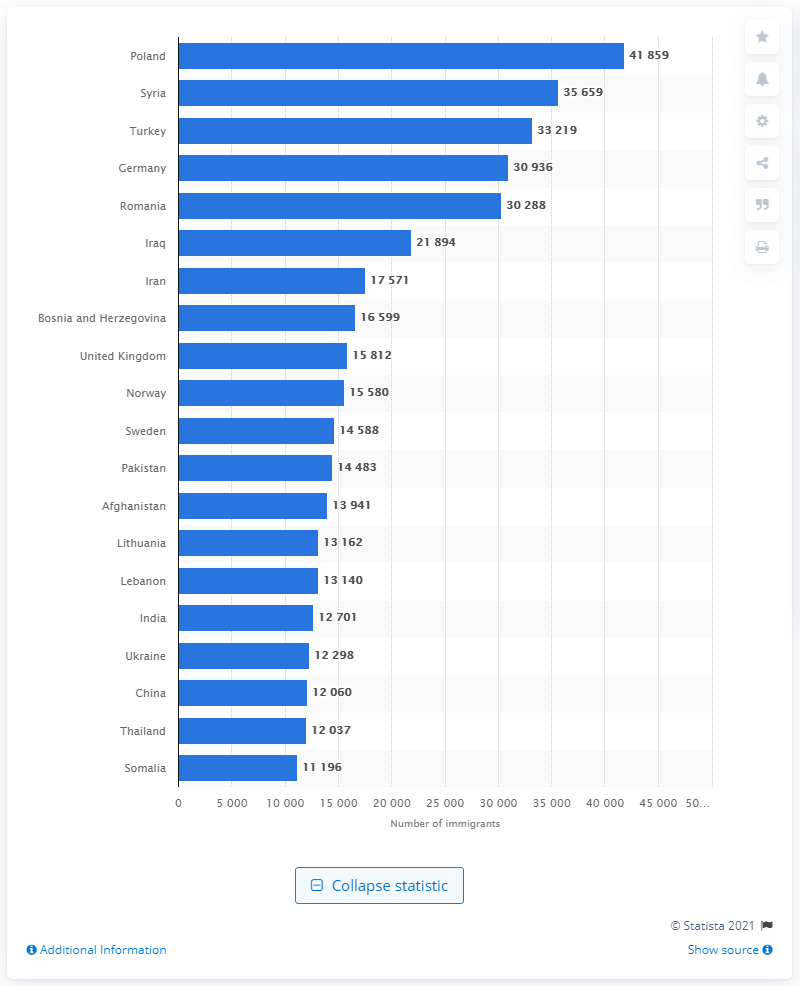Specify some key components in this picture. As of January 1, 2021, the estimated number of people living in Denmark was approximately 41,859. The country that the majority of immigrants came from was Poland. 